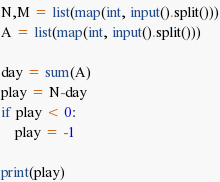<code> <loc_0><loc_0><loc_500><loc_500><_Python_>
N,M = list(map(int, input().split()))
A = list(map(int, input().split()))

day = sum(A)
play = N-day
if play < 0:
    play = -1

print(play)</code> 